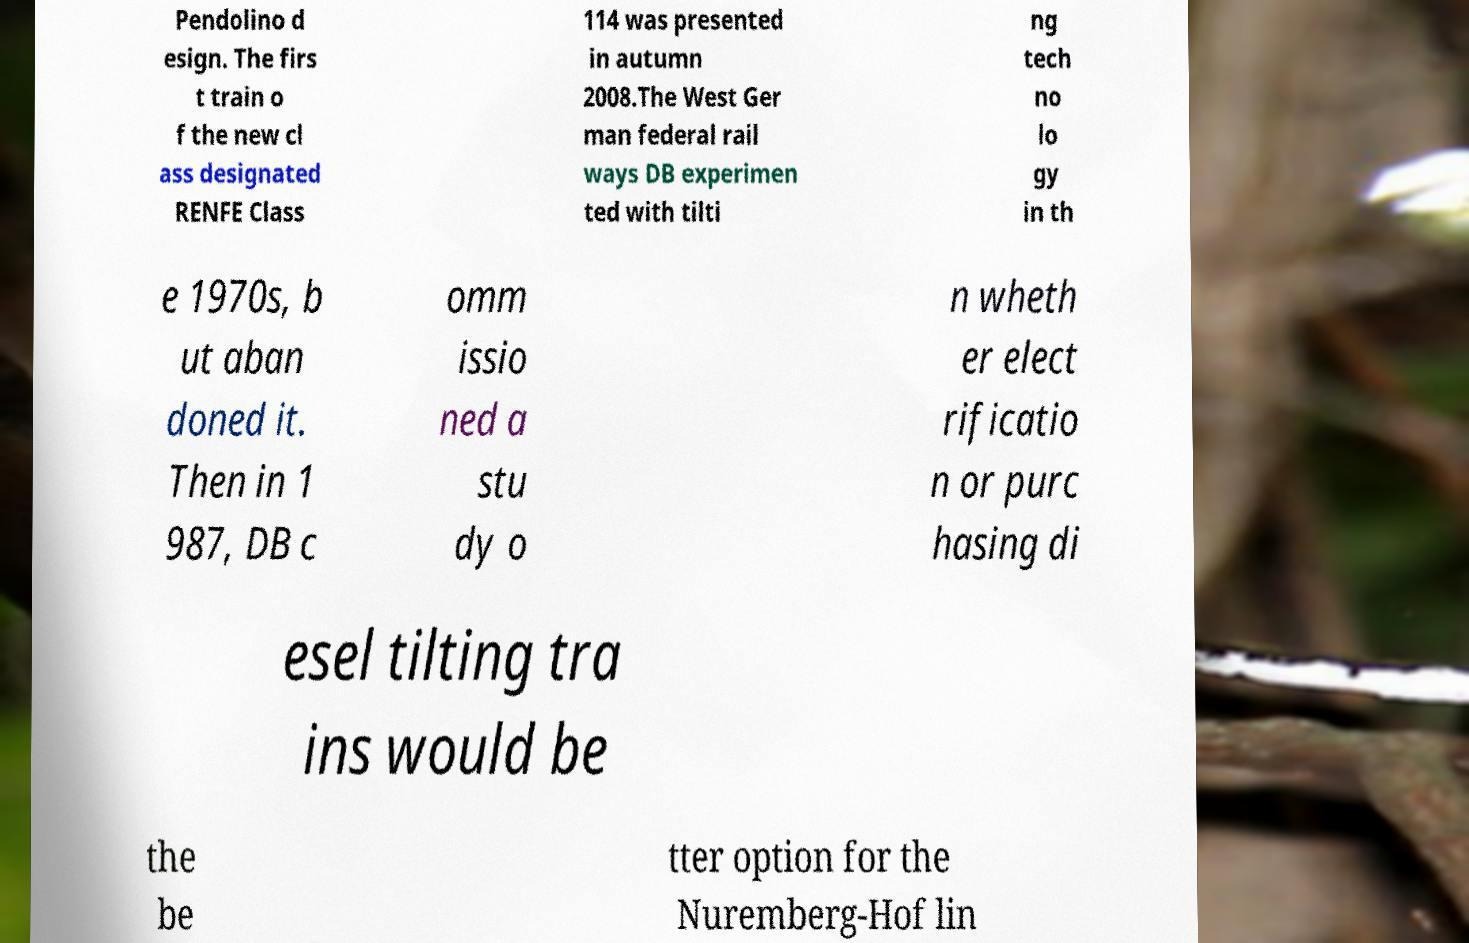Can you read and provide the text displayed in the image?This photo seems to have some interesting text. Can you extract and type it out for me? Pendolino d esign. The firs t train o f the new cl ass designated RENFE Class 114 was presented in autumn 2008.The West Ger man federal rail ways DB experimen ted with tilti ng tech no lo gy in th e 1970s, b ut aban doned it. Then in 1 987, DB c omm issio ned a stu dy o n wheth er elect rificatio n or purc hasing di esel tilting tra ins would be the be tter option for the Nuremberg-Hof lin 